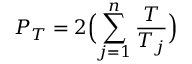Convert formula to latex. <formula><loc_0><loc_0><loc_500><loc_500>P _ { T } = 2 \left ( \sum _ { j = 1 } ^ { n } \frac { T } { T _ { j } } \right )</formula> 